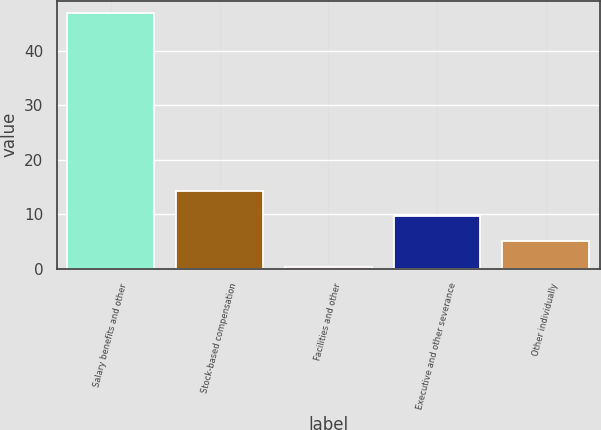Convert chart. <chart><loc_0><loc_0><loc_500><loc_500><bar_chart><fcel>Salary benefits and other<fcel>Stock-based compensation<fcel>Facilities and other<fcel>Executive and other severance<fcel>Other individually<nl><fcel>46.8<fcel>14.32<fcel>0.4<fcel>9.68<fcel>5.04<nl></chart> 